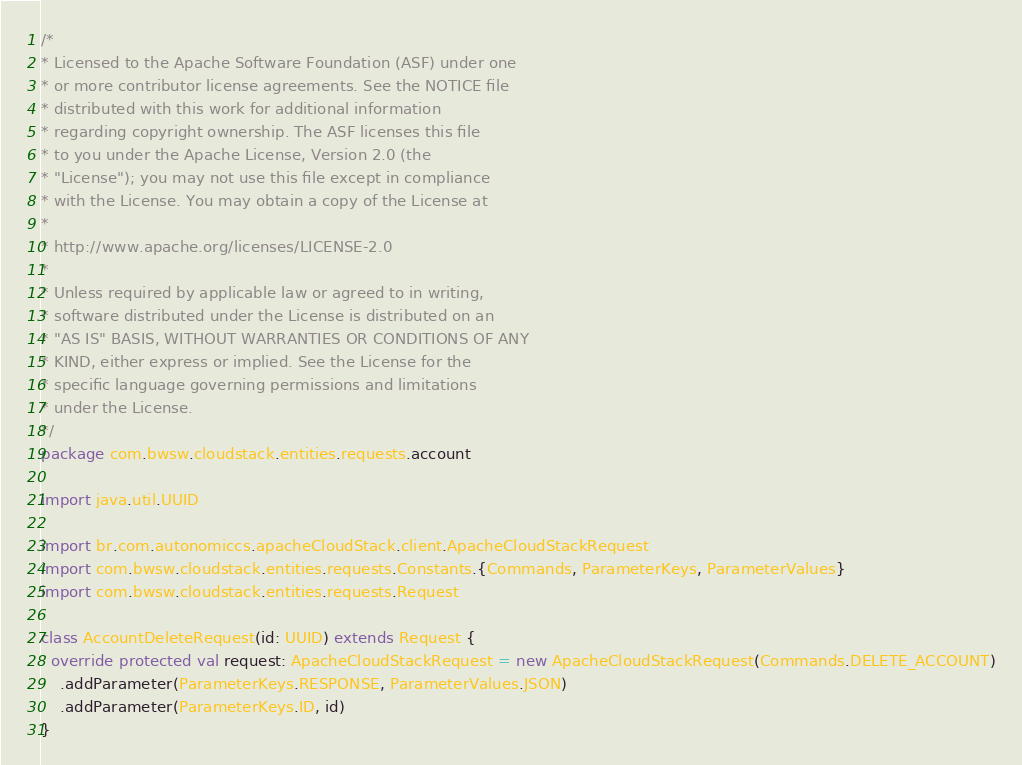<code> <loc_0><loc_0><loc_500><loc_500><_Scala_>/*
* Licensed to the Apache Software Foundation (ASF) under one
* or more contributor license agreements. See the NOTICE file
* distributed with this work for additional information
* regarding copyright ownership. The ASF licenses this file
* to you under the Apache License, Version 2.0 (the
* "License"); you may not use this file except in compliance
* with the License. You may obtain a copy of the License at
*
* http://www.apache.org/licenses/LICENSE-2.0
*
* Unless required by applicable law or agreed to in writing,
* software distributed under the License is distributed on an
* "AS IS" BASIS, WITHOUT WARRANTIES OR CONDITIONS OF ANY
* KIND, either express or implied. See the License for the
* specific language governing permissions and limitations
* under the License.
*/
package com.bwsw.cloudstack.entities.requests.account

import java.util.UUID

import br.com.autonomiccs.apacheCloudStack.client.ApacheCloudStackRequest
import com.bwsw.cloudstack.entities.requests.Constants.{Commands, ParameterKeys, ParameterValues}
import com.bwsw.cloudstack.entities.requests.Request

class AccountDeleteRequest(id: UUID) extends Request {
  override protected val request: ApacheCloudStackRequest = new ApacheCloudStackRequest(Commands.DELETE_ACCOUNT)
    .addParameter(ParameterKeys.RESPONSE, ParameterValues.JSON)
    .addParameter(ParameterKeys.ID, id)
}
</code> 